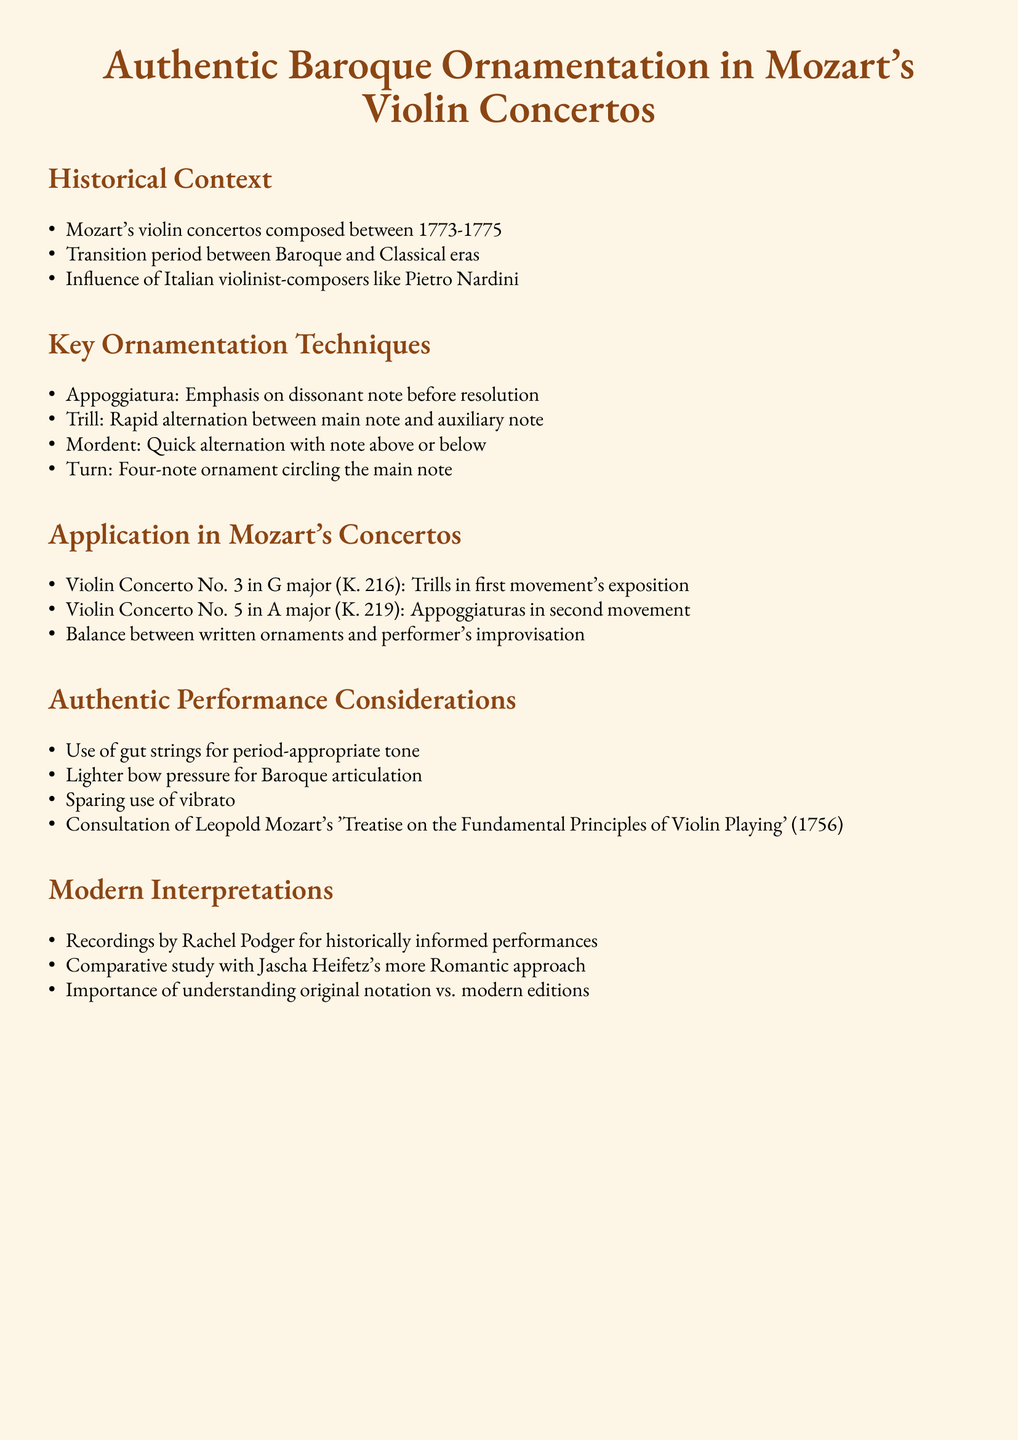What years were Mozart's violin concertos composed? The document states that Mozart's violin concertos were composed between 1773 and 1775.
Answer: 1773-1775 Who were significant influences on Mozart’s violin concertos? The document mentions Italian violinist-composers like Pietro Nardini as significant influences.
Answer: Pietro Nardini What is an Appoggiatura? The document defines an Appoggiatura as an emphasis on a dissonant note before resolution.
Answer: Emphasis on dissonant note before resolution In which concerto are trills found in the first movement's exposition? According to the document, trills are present in the Violin Concerto No. 3 in G major (K. 216).
Answer: Violin Concerto No. 3 in G major (K. 216) What is a recommended performance consideration for authentic interpretations? The document suggests the use of gut strings for period-appropriate tone.
Answer: Use of gut strings Who wrote the 'Treatise on the Fundamental Principles of Violin Playing'? The document states that Leopold Mozart wrote this treatise.
Answer: Leopold Mozart What is a modern interpretation mentioned in the document? The document references recordings by Rachel Podger as a modern interpretation.
Answer: Recordings by Rachel Podger How are modern editions different from original notations? The document emphasizes the importance of understanding the difference between original notation and modern editions.
Answer: Understanding original notation vs. modern editions What technique involves a rapid alternation between two notes? The document describes the trill as a technique that involves rapid alternation between the main note and an auxiliary note.
Answer: Trill 